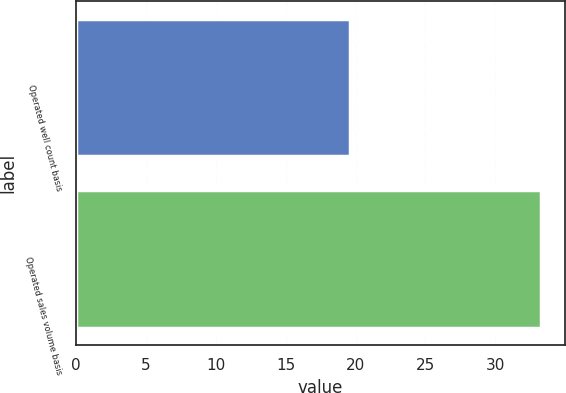<chart> <loc_0><loc_0><loc_500><loc_500><bar_chart><fcel>Operated well count basis<fcel>Operated sales volume basis<nl><fcel>19.6<fcel>33.3<nl></chart> 